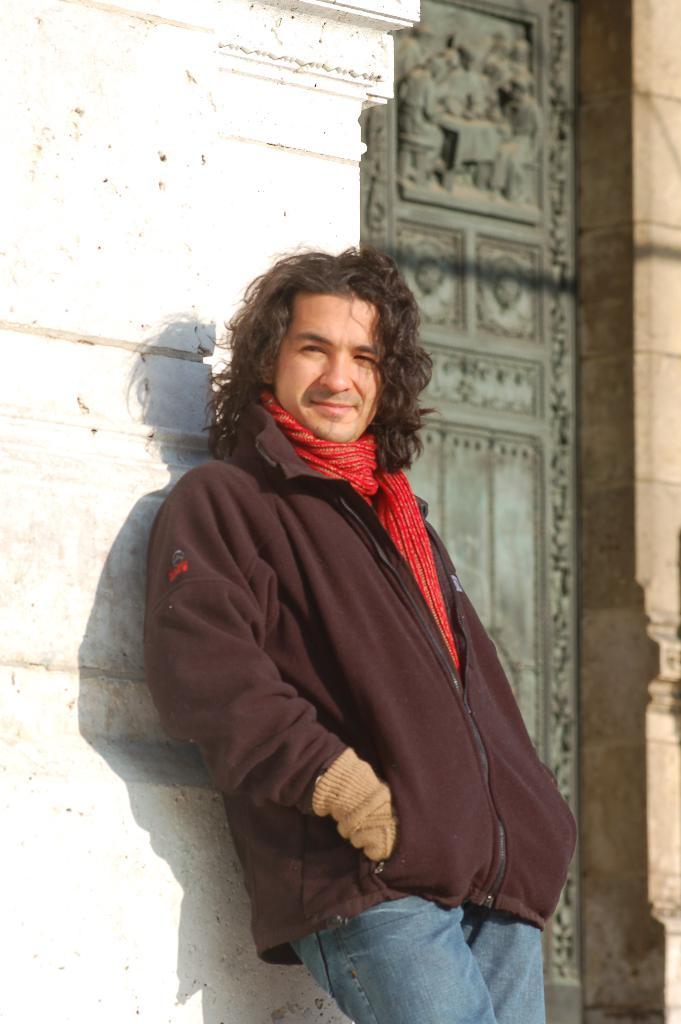What is the main subject of the image? There is a man standing in the image. Where is the man located in the image? The man is at the bottom of the image. What can be seen in the background of the image? There is a wall and a door in the background of the image. Is the man driving a car in the image? No, there is no car or driving activity present in the image. 